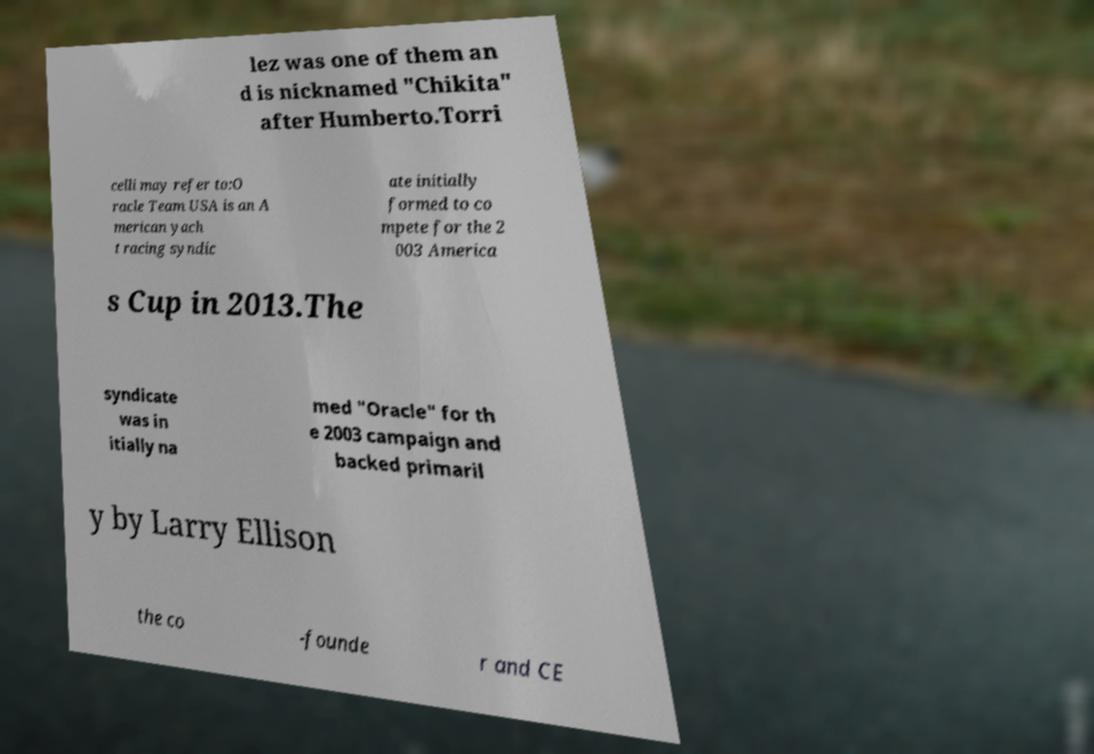Could you assist in decoding the text presented in this image and type it out clearly? lez was one of them an d is nicknamed "Chikita" after Humberto.Torri celli may refer to:O racle Team USA is an A merican yach t racing syndic ate initially formed to co mpete for the 2 003 America s Cup in 2013.The syndicate was in itially na med "Oracle" for th e 2003 campaign and backed primaril y by Larry Ellison the co -founde r and CE 